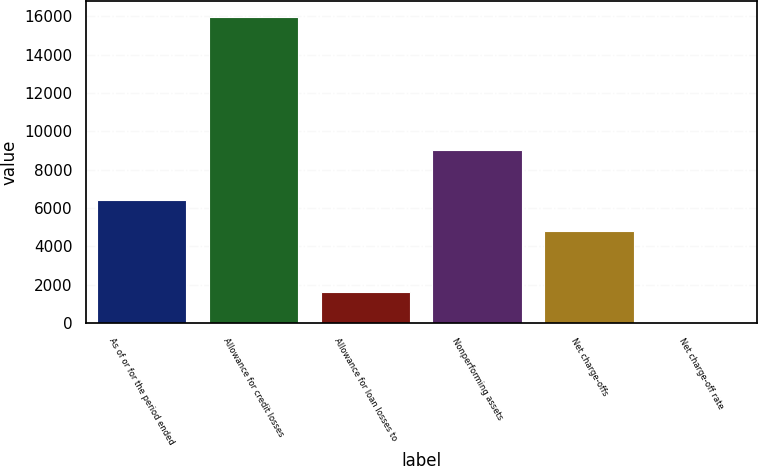<chart> <loc_0><loc_0><loc_500><loc_500><bar_chart><fcel>As of or for the period ended<fcel>Allowance for credit losses<fcel>Allowance for loan losses to<fcel>Nonperforming assets<fcel>Net charge-offs<fcel>Net charge-off rate<nl><fcel>6390<fcel>15974<fcel>1597.98<fcel>9017<fcel>4792.66<fcel>0.64<nl></chart> 